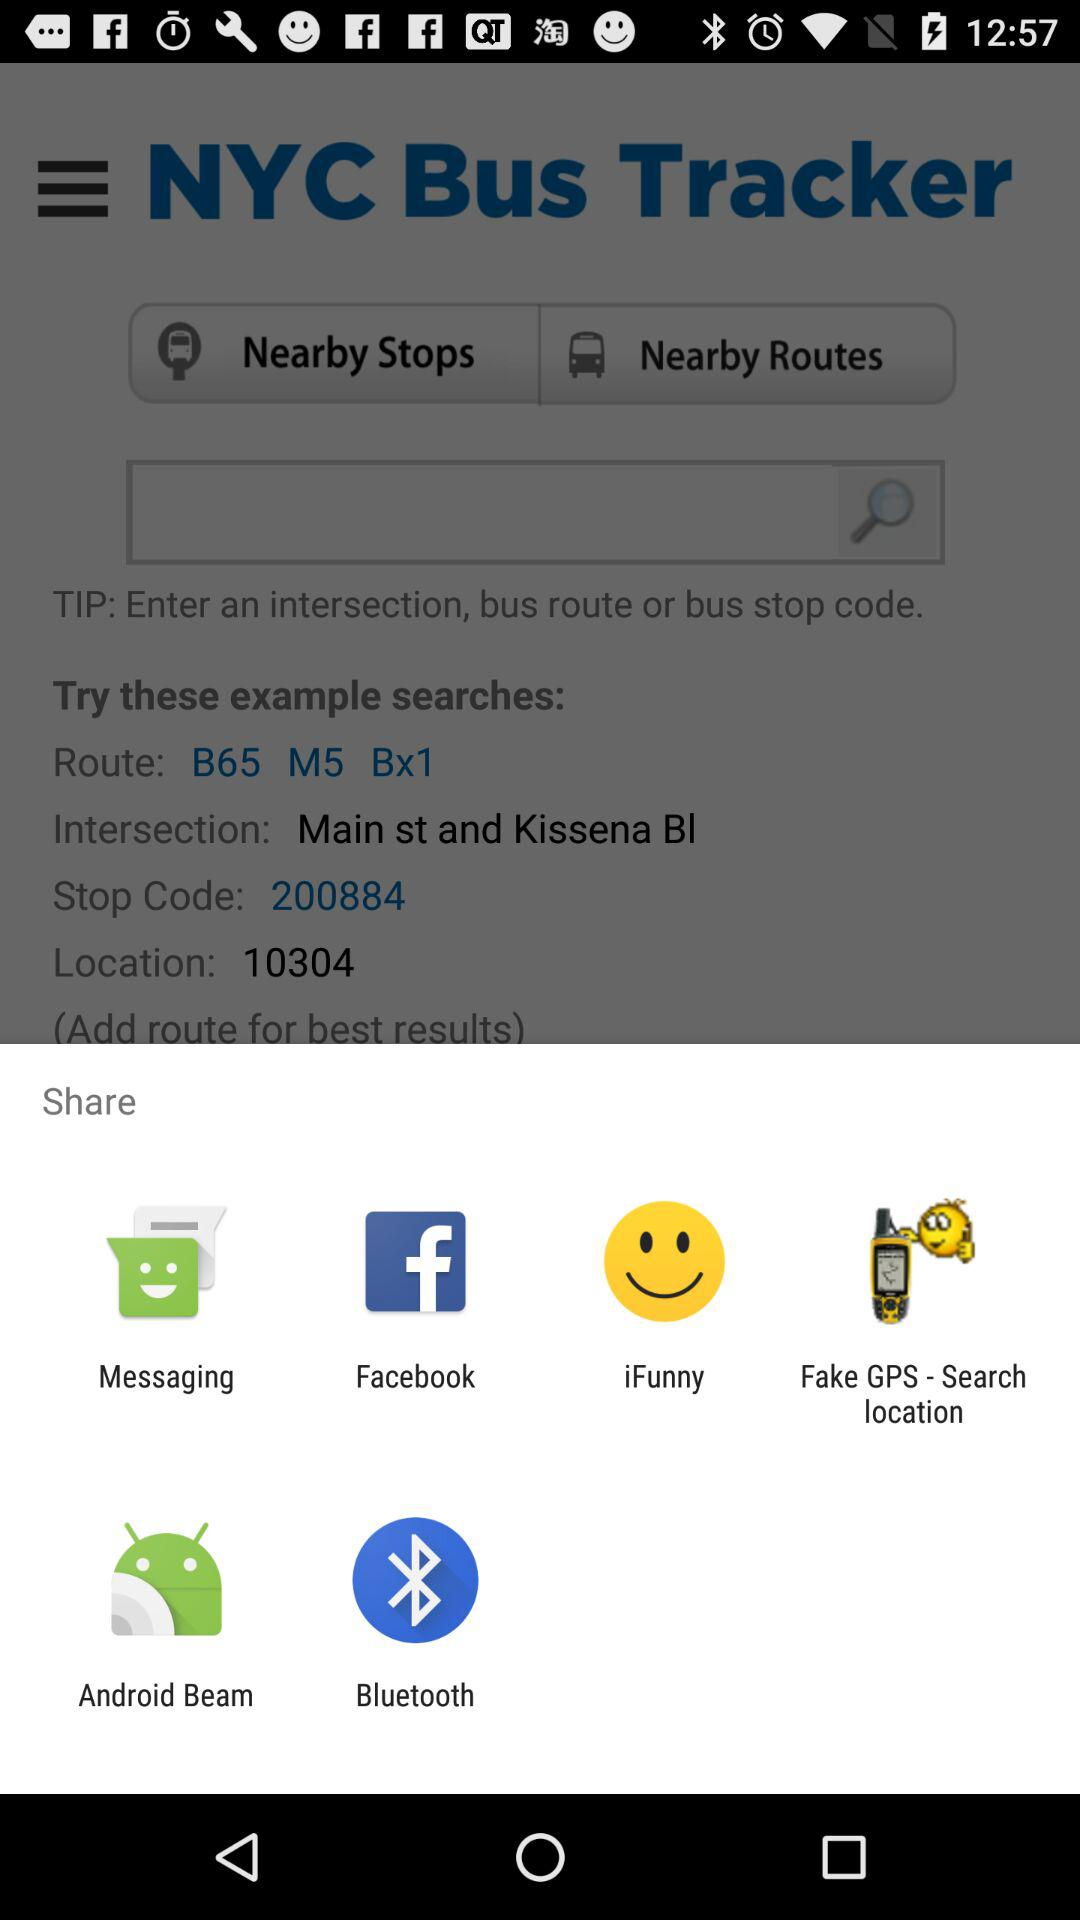What is the location code? The location code is 10304. 